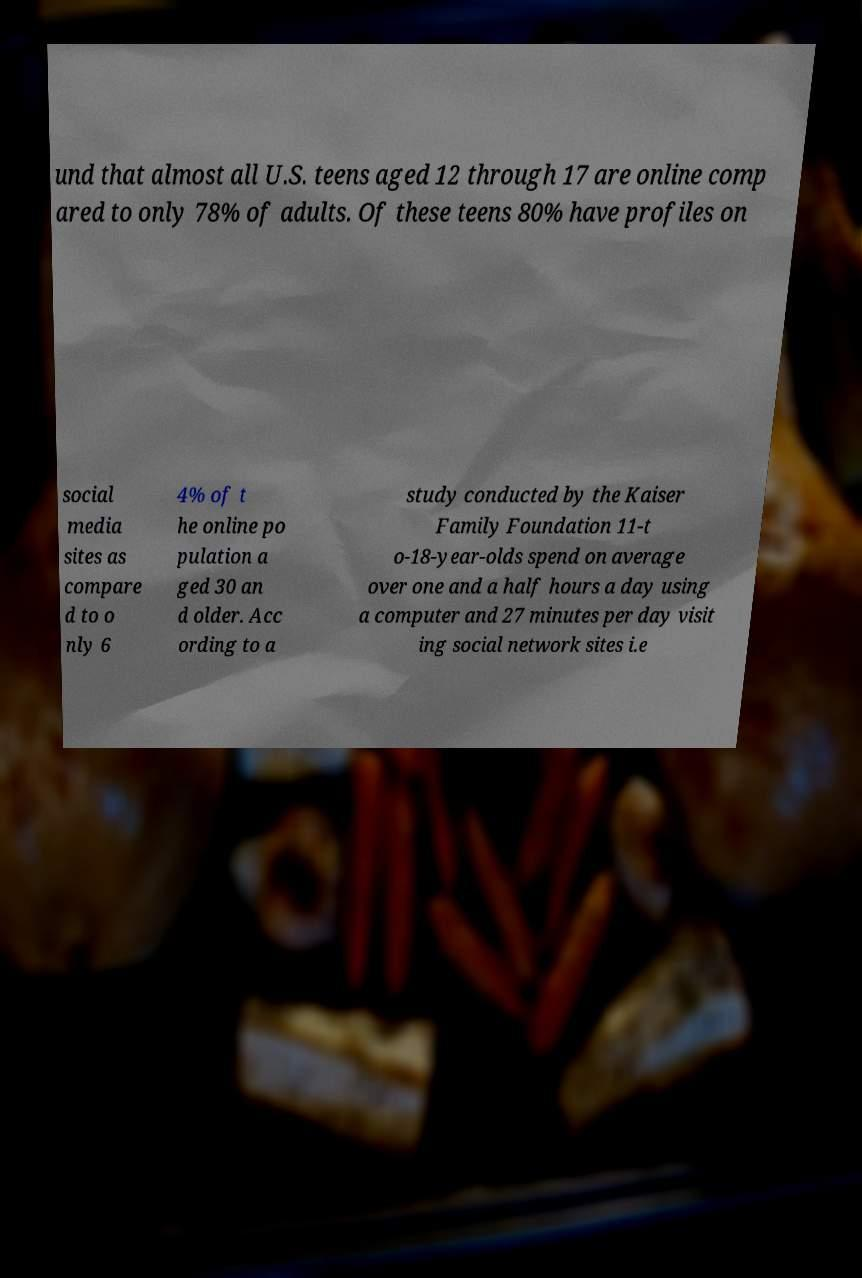There's text embedded in this image that I need extracted. Can you transcribe it verbatim? und that almost all U.S. teens aged 12 through 17 are online comp ared to only 78% of adults. Of these teens 80% have profiles on social media sites as compare d to o nly 6 4% of t he online po pulation a ged 30 an d older. Acc ording to a study conducted by the Kaiser Family Foundation 11-t o-18-year-olds spend on average over one and a half hours a day using a computer and 27 minutes per day visit ing social network sites i.e 